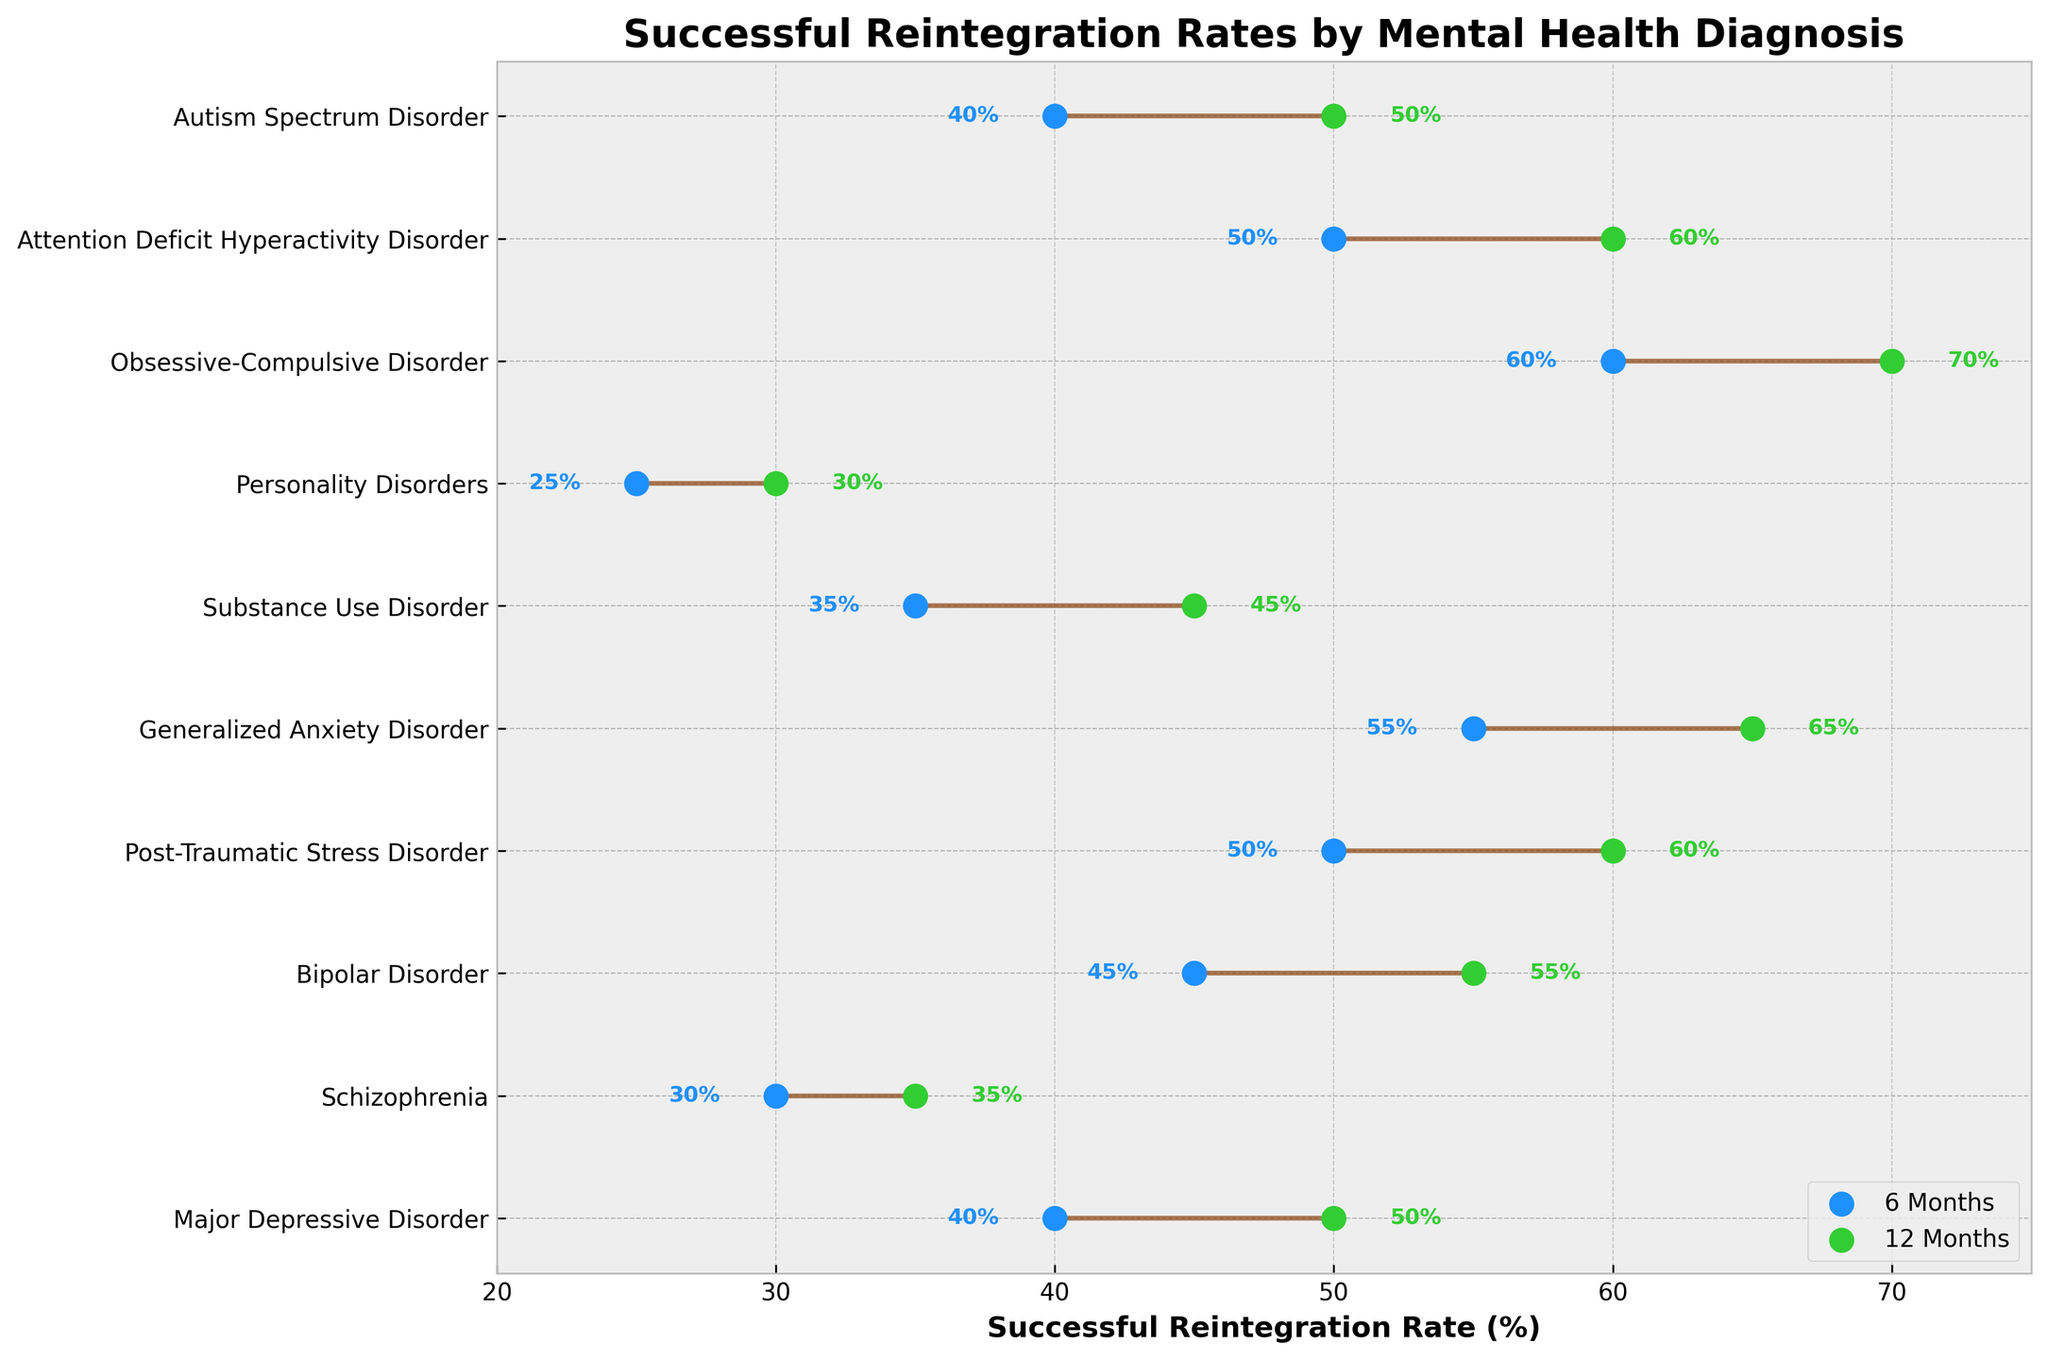What's the title of the plot? The title of a plot is usually found at the top and directly describes the main subject of the visualized data. In this case, the title is located at the top-center of the plot.
Answer: Successful Reintegration Rates by Mental Health Diagnosis What color represents the successful reintegration rate at 6 months? The color coding in the plot is evident by looking at the legend. In the legend, the color associated with "6 Months" helps to identify it in the plot.
Answer: Blue Which mental health diagnosis has the highest successful reintegration rate at 12 months? The highest successful reintegration rate at 12 months can be found by looking at the rightmost point of each dumbbell. The diagnosis associated with the highest value (70%) is the answer.
Answer: Obsessive-Compulsive Disorder What is the difference in successful reintegration rates at 12 months between Major Depressive Disorder and Schizophrenia? First, identify the 12-month rates for both disorders from the right-side points of their respective dumbbells. For Major Depressive Disorder, the rate is 50%, and for Schizophrenia, it is 35%. Subtract the lower rate (35%) from the higher rate (50%).
Answer: 15% Which diagnosis shows the greatest improvement in successful reintegration rates from 6 months to 12 months? To determine the greatest improvement, observe the length of each dumbbell which represents the difference between the 6-month and 12-month rates. Find the diagnosis whose dumbbell line segment is the longest.
Answer: Generalized Anxiety Disorder How many mental health diagnoses have a 6-month successful reintegration rate of at least 50%? Count the blue points (representing 6-month rates) that are at or above 50%. These correspond to the diagnoses with a 6-month rate of at least 50%.
Answer: Four Which mental health diagnosis has the smallest rate difference between 6 months and 12 months, and what is the value of the difference? The smallest difference can be found by looking for the shortest dumbbell line segment. For each diagnosis, calculate the difference between the 12-month and 6-month rates, identify the minimum difference, and then find the associated diagnosis.
Answer: Personality Disorders, 5% For Attention Deficit Hyperactivity Disorder, how much does the successful reintegration rate increase from 6 months to 12 months? Locate the dumbbell for ADHD and find the values at 6 months and 12 months. Subtract the 6-month rate from the 12-month rate.
Answer: 10% How many diagnoses have a 12-month successful reintegration rate of at least 50%? Count the green points (representing 12-month rates) that are at or above 50%. These represent the diagnoses with a 12-month rate of at least 50%.
Answer: Eight Which diagnosis has a more significant increase in successful reintegration rate from 6 months to 12 months, Bipolar Disorder or Substance Use Disorder, and by how much is it larger? First, find the rate differences for both diagnoses: Bipolar Disorder (55%-45%) = 10%, Substance Use Disorder (45%-35%) = 10%. Both have the same increase.
Answer: Both have the same increase, 10% 